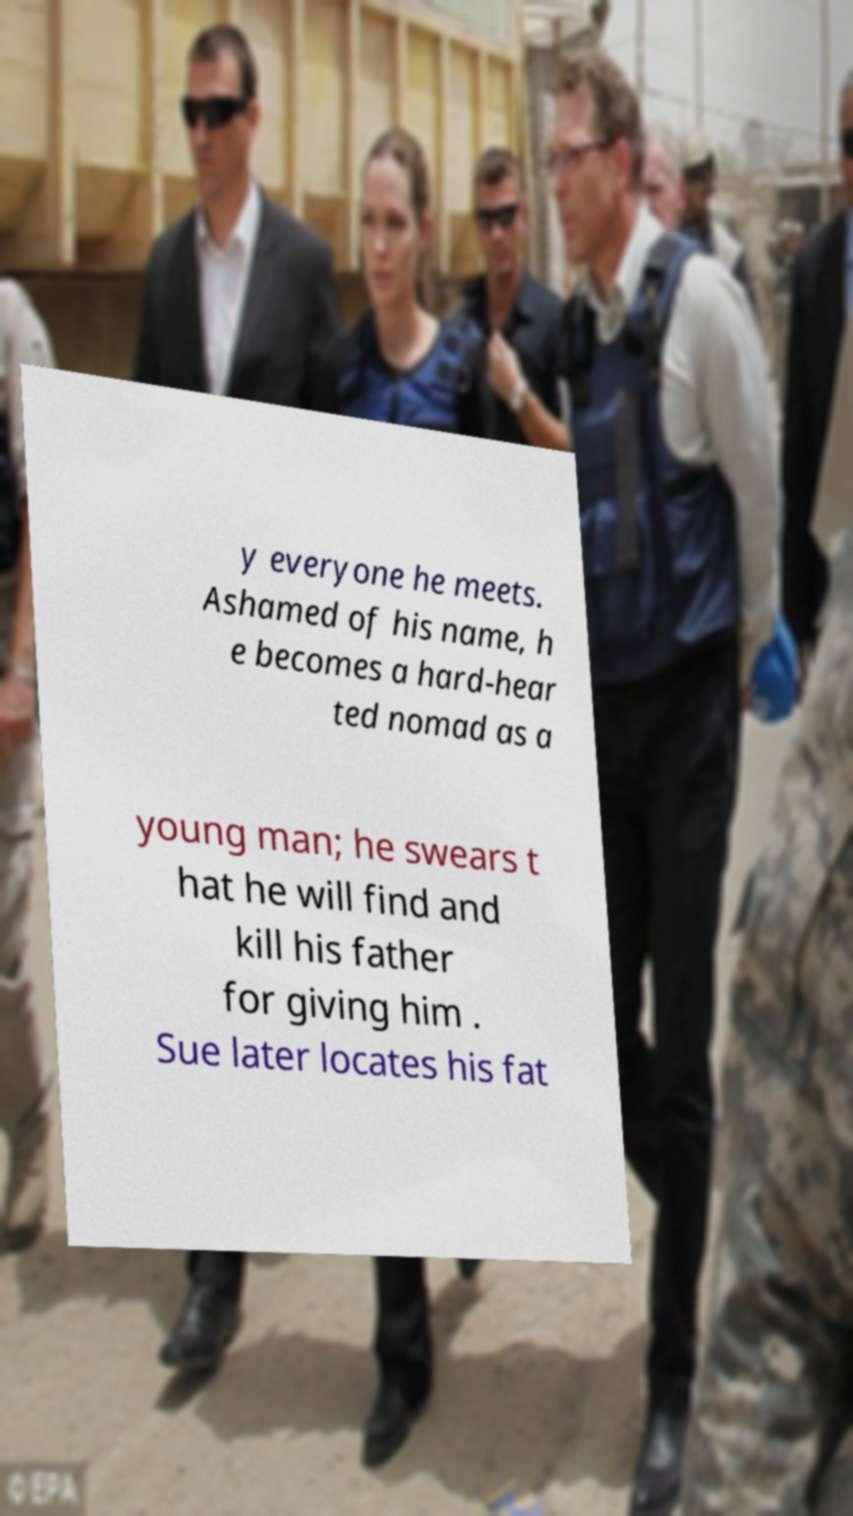Can you accurately transcribe the text from the provided image for me? y everyone he meets. Ashamed of his name, h e becomes a hard-hear ted nomad as a young man; he swears t hat he will find and kill his father for giving him . Sue later locates his fat 